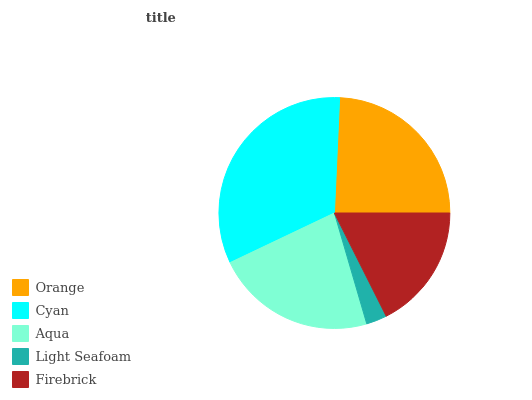Is Light Seafoam the minimum?
Answer yes or no. Yes. Is Cyan the maximum?
Answer yes or no. Yes. Is Aqua the minimum?
Answer yes or no. No. Is Aqua the maximum?
Answer yes or no. No. Is Cyan greater than Aqua?
Answer yes or no. Yes. Is Aqua less than Cyan?
Answer yes or no. Yes. Is Aqua greater than Cyan?
Answer yes or no. No. Is Cyan less than Aqua?
Answer yes or no. No. Is Aqua the high median?
Answer yes or no. Yes. Is Aqua the low median?
Answer yes or no. Yes. Is Light Seafoam the high median?
Answer yes or no. No. Is Cyan the low median?
Answer yes or no. No. 